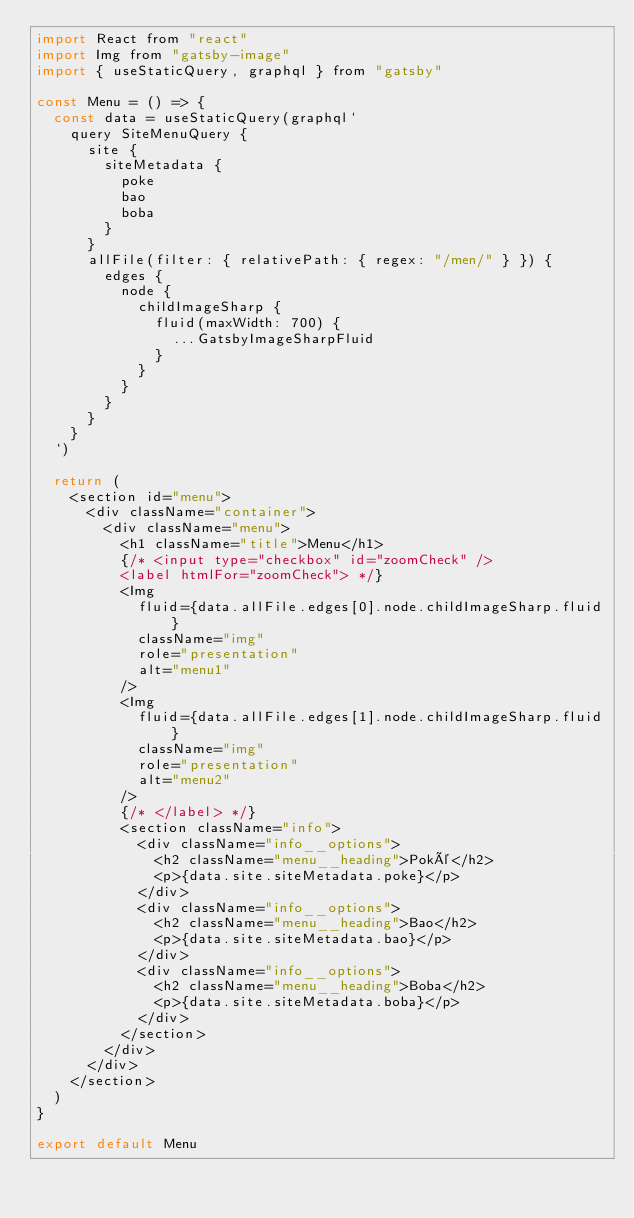<code> <loc_0><loc_0><loc_500><loc_500><_JavaScript_>import React from "react"
import Img from "gatsby-image"
import { useStaticQuery, graphql } from "gatsby"

const Menu = () => {
  const data = useStaticQuery(graphql`
    query SiteMenuQuery {
      site {
        siteMetadata {
          poke
          bao
          boba
        }
      }
      allFile(filter: { relativePath: { regex: "/men/" } }) {
        edges {
          node {
            childImageSharp {
              fluid(maxWidth: 700) {
                ...GatsbyImageSharpFluid
              }
            }
          }
        }
      }
    }
  `)

  return (
    <section id="menu">
      <div className="container">
        <div className="menu">
          <h1 className="title">Menu</h1>
          {/* <input type="checkbox" id="zoomCheck" />
          <label htmlFor="zoomCheck"> */}
          <Img
            fluid={data.allFile.edges[0].node.childImageSharp.fluid}
            className="img"
            role="presentation"
            alt="menu1"
          />
          <Img
            fluid={data.allFile.edges[1].node.childImageSharp.fluid}
            className="img"
            role="presentation"
            alt="menu2"
          />
          {/* </label> */}
          <section className="info">
            <div className="info__options">
              <h2 className="menu__heading">Poké</h2>
              <p>{data.site.siteMetadata.poke}</p>
            </div>
            <div className="info__options">
              <h2 className="menu__heading">Bao</h2>
              <p>{data.site.siteMetadata.bao}</p>
            </div>
            <div className="info__options">
              <h2 className="menu__heading">Boba</h2>
              <p>{data.site.siteMetadata.boba}</p>
            </div>
          </section>
        </div>
      </div>
    </section>
  )
}

export default Menu
</code> 